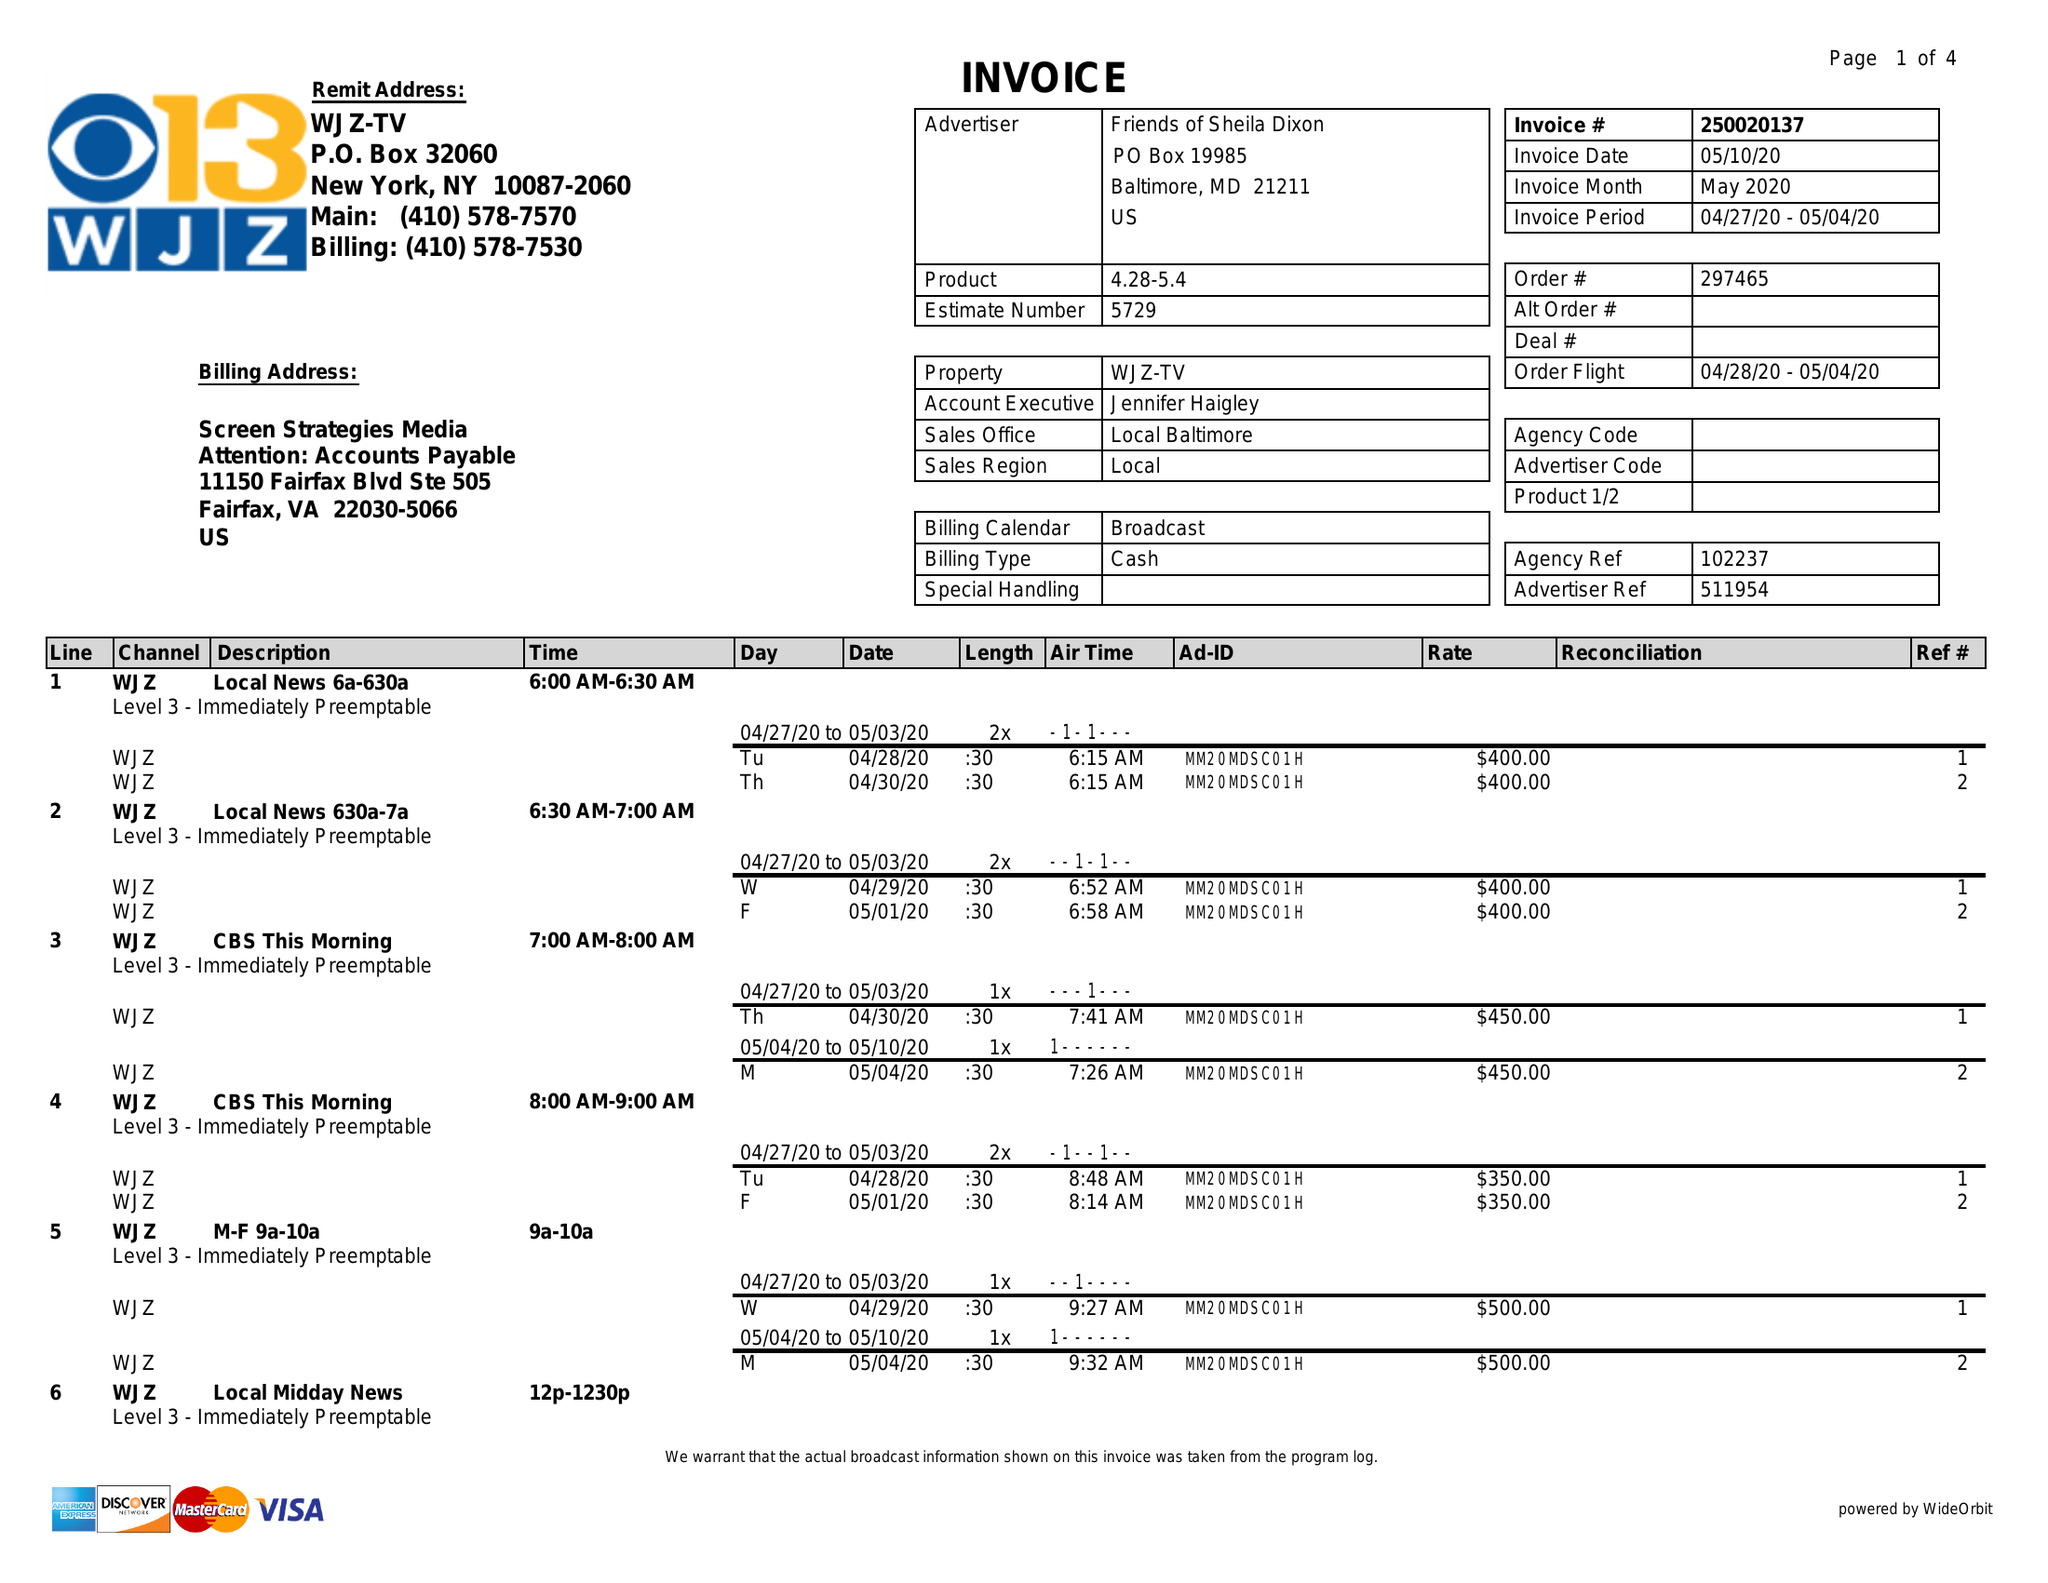What is the value for the flight_to?
Answer the question using a single word or phrase. 05/04/20 